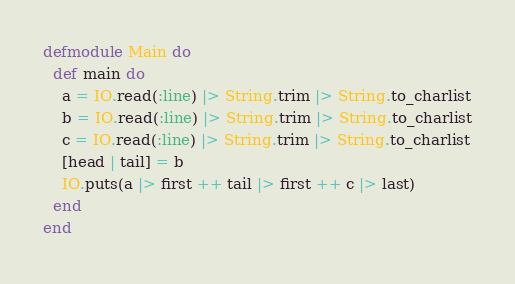Convert code to text. <code><loc_0><loc_0><loc_500><loc_500><_Elixir_>defmodule Main do
  def main do
    a = IO.read(:line) |> String.trim |> String.to_charlist
    b = IO.read(:line) |> String.trim |> String.to_charlist
    c = IO.read(:line) |> String.trim |> String.to_charlist
    [head | tail] = b
    IO.puts(a |> first ++ tail |> first ++ c |> last)
  end
end
</code> 